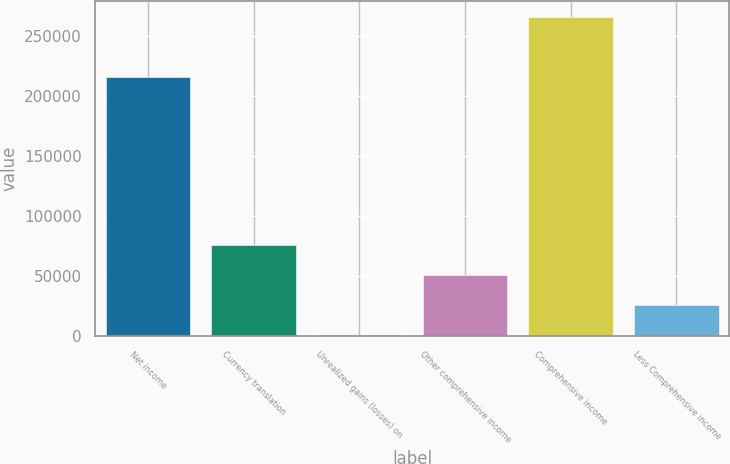Convert chart. <chart><loc_0><loc_0><loc_500><loc_500><bar_chart><fcel>Net income<fcel>Currency translation<fcel>Unrealized gains (losses) on<fcel>Other comprehensive income<fcel>Comprehensive income<fcel>Less Comprehensive income<nl><fcel>216358<fcel>76234.3<fcel>1324<fcel>51264.2<fcel>266298<fcel>26294.1<nl></chart> 